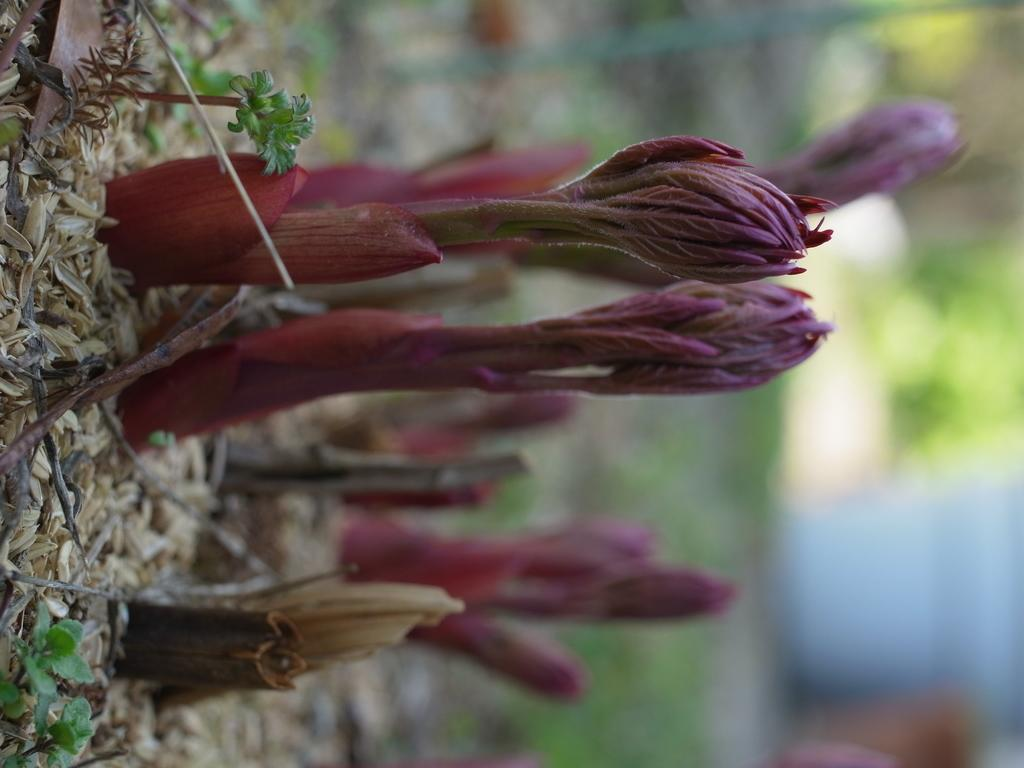What type of plant is in the image? There is a plant in the image with magenta color flowers. What color are the flowers on the plant? The flowers on the plant are magenta. What other parts of the plant can be seen in the image? The plant has leaves, both dry and green. What else is on the ground in the image? There are sticks on the ground in the image. What type of fowl can be seen in the image? There is no fowl present in the image; it features a plant with magenta flowers, leaves, and sticks on the ground. 